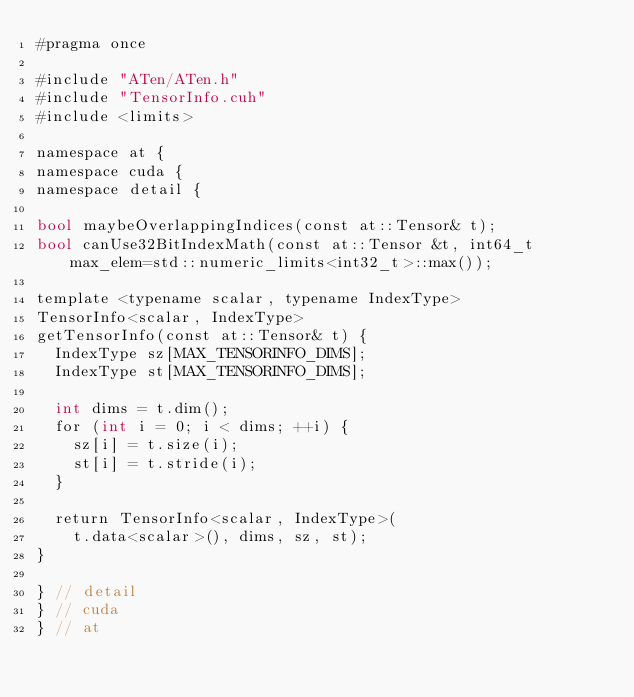Convert code to text. <code><loc_0><loc_0><loc_500><loc_500><_Cuda_>#pragma once

#include "ATen/ATen.h"
#include "TensorInfo.cuh"
#include <limits>

namespace at {
namespace cuda {
namespace detail {

bool maybeOverlappingIndices(const at::Tensor& t);
bool canUse32BitIndexMath(const at::Tensor &t, int64_t max_elem=std::numeric_limits<int32_t>::max());

template <typename scalar, typename IndexType>
TensorInfo<scalar, IndexType>
getTensorInfo(const at::Tensor& t) {
  IndexType sz[MAX_TENSORINFO_DIMS];
  IndexType st[MAX_TENSORINFO_DIMS];

  int dims = t.dim();
  for (int i = 0; i < dims; ++i) {
    sz[i] = t.size(i);
    st[i] = t.stride(i);
  }

  return TensorInfo<scalar, IndexType>(
    t.data<scalar>(), dims, sz, st);
}

} // detail
} // cuda
} // at
</code> 